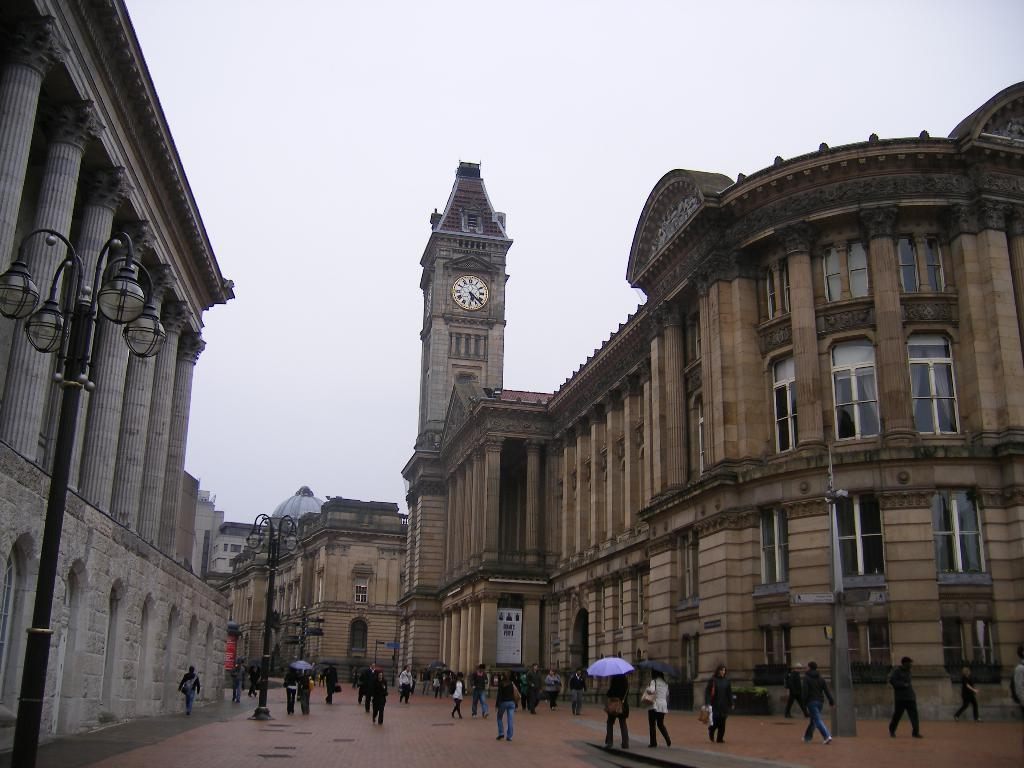What type of structures can be seen in the image? There are buildings, light poles, and a clock tower in the image. What architectural features are present in the image? There are pillars in the image. Are there any people in the image? Yes, there are people in the image. What is the weather like in the image? The sky is cloudy in the image. What object can be seen in the image that might display information? There is a board in the image. How are some people in the image protecting themselves from the weather? Two people are holding umbrellas in the image. What type of soup is being served in the image? There is no soup present in the image. What are the people in the image reading? There is no reading material or activity depicted in the image. Can you see a pear in the image? There is no pear present in the image. 